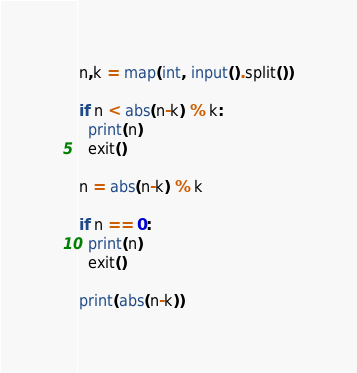<code> <loc_0><loc_0><loc_500><loc_500><_Python_>n,k = map(int, input().split())

if n < abs(n-k) % k:
  print(n)
  exit()

n = abs(n-k) % k

if n == 0:
  print(n)
  exit()

print(abs(n-k))</code> 